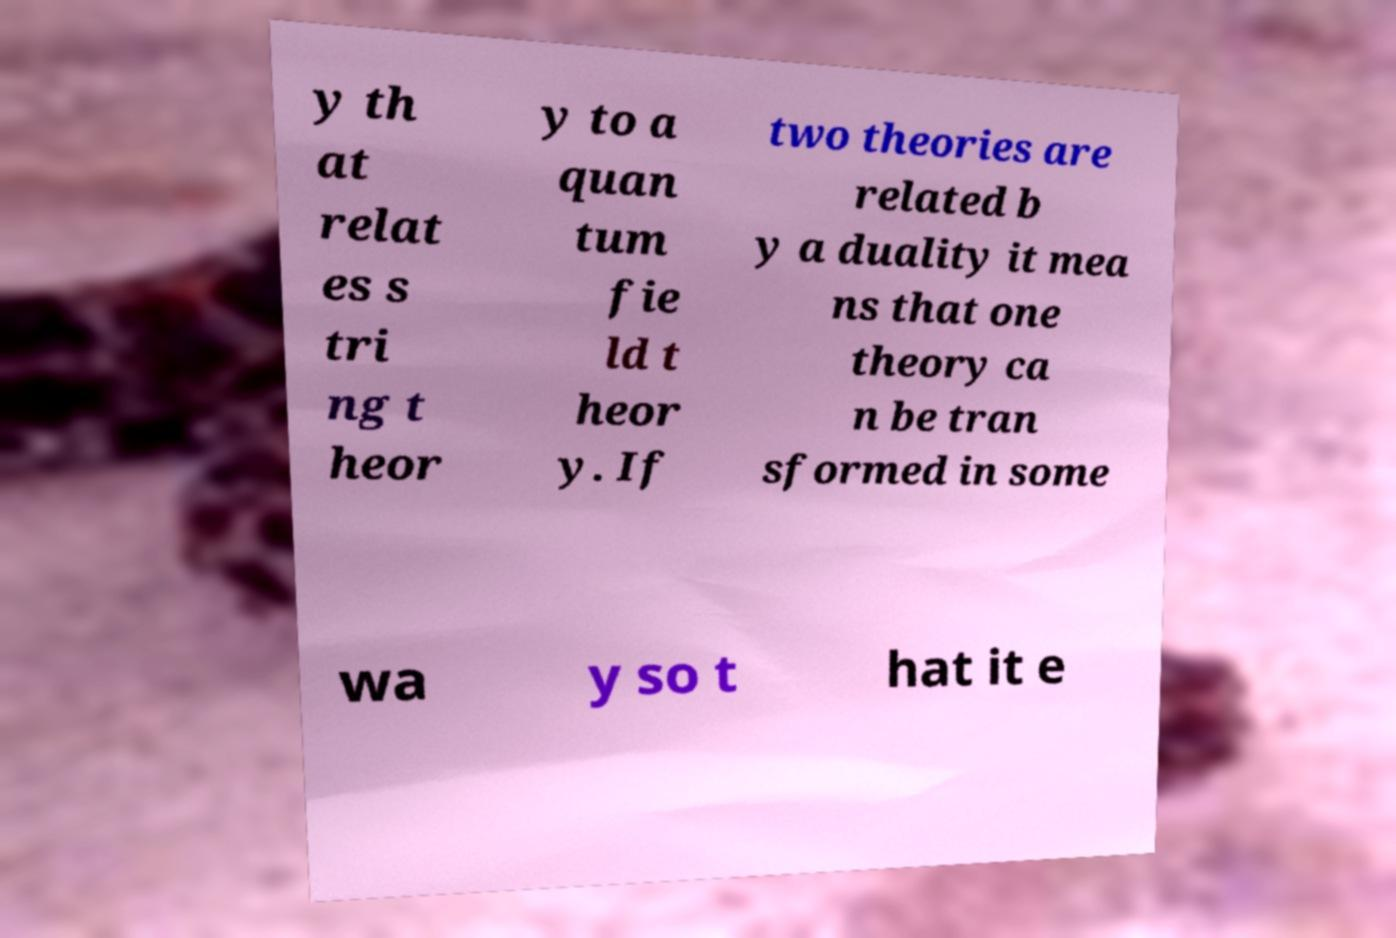Can you accurately transcribe the text from the provided image for me? y th at relat es s tri ng t heor y to a quan tum fie ld t heor y. If two theories are related b y a duality it mea ns that one theory ca n be tran sformed in some wa y so t hat it e 